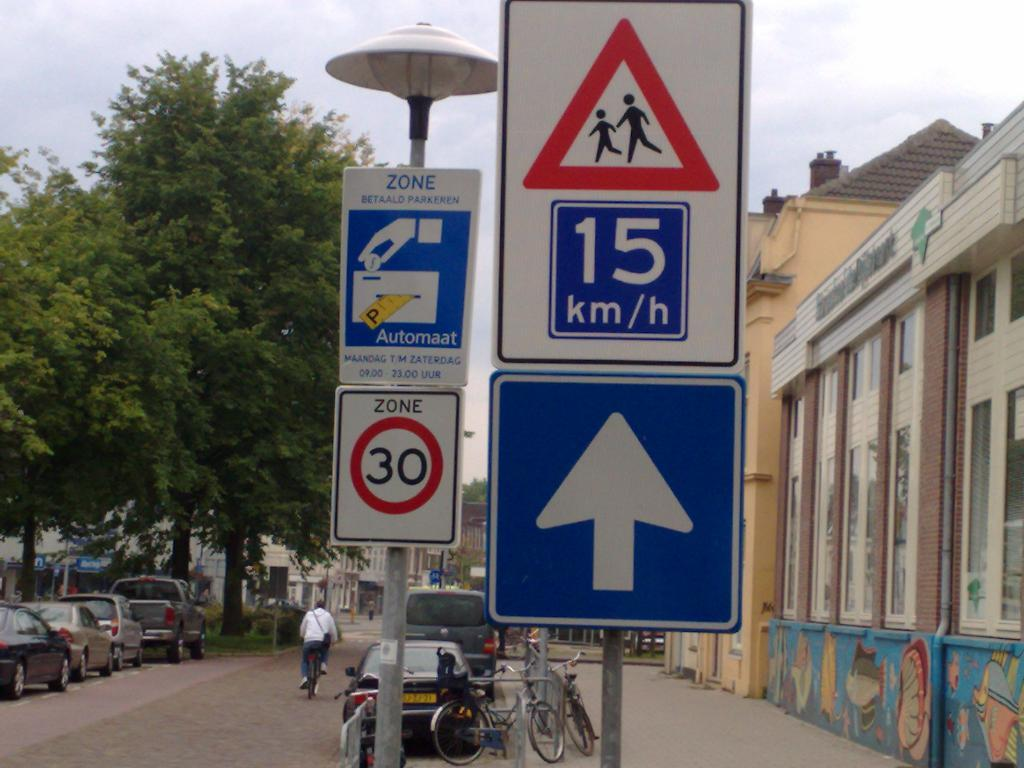<image>
Provide a brief description of the given image. The speed in zone 30 is 15 km/h but be careful for pedestrians 